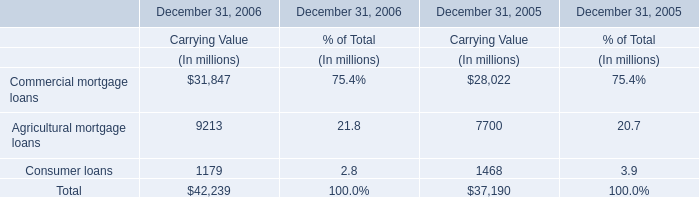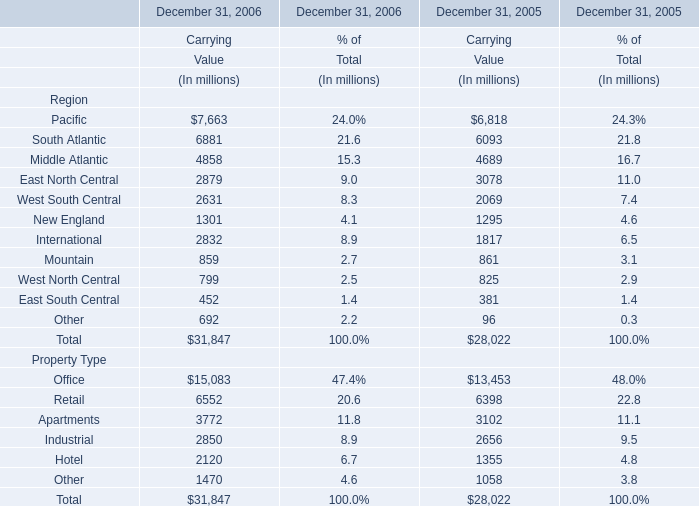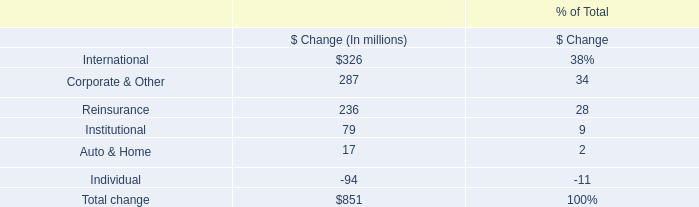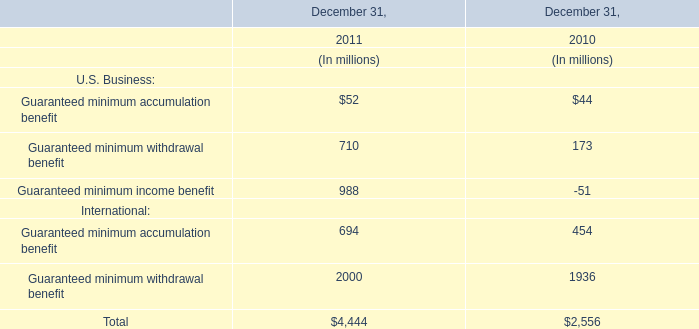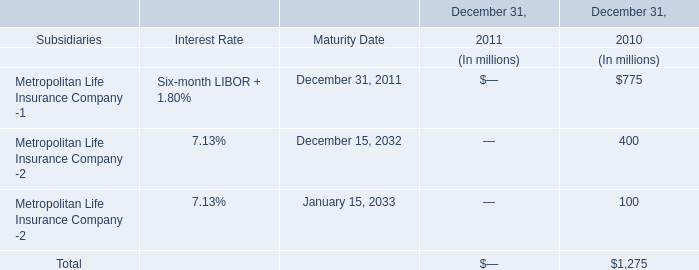Which year is Agricultural mortgage loans at Carrying Value the most? 
Answer: 2006. 